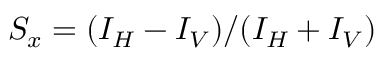<formula> <loc_0><loc_0><loc_500><loc_500>S _ { x } = ( I _ { H } - I _ { V } ) / ( I _ { H } + I _ { V } )</formula> 